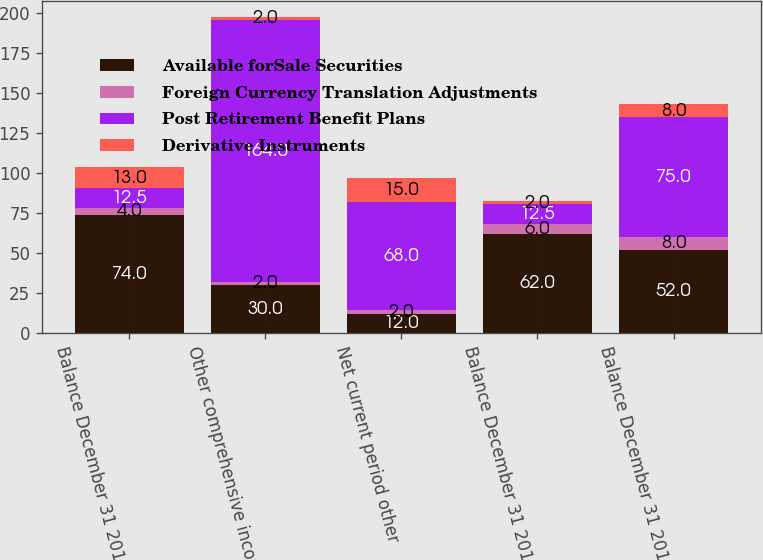Convert chart to OTSL. <chart><loc_0><loc_0><loc_500><loc_500><stacked_bar_chart><ecel><fcel>Balance December 31 2012<fcel>Other comprehensive income<fcel>Net current period other<fcel>Balance December 31 2013<fcel>Balance December 31 2015<nl><fcel>Available forSale Securities<fcel>74<fcel>30<fcel>12<fcel>62<fcel>52<nl><fcel>Foreign Currency Translation Adjustments<fcel>4<fcel>2<fcel>2<fcel>6<fcel>8<nl><fcel>Post Retirement Benefit Plans<fcel>12.5<fcel>164<fcel>68<fcel>12.5<fcel>75<nl><fcel>Derivative Instruments<fcel>13<fcel>2<fcel>15<fcel>2<fcel>8<nl></chart> 